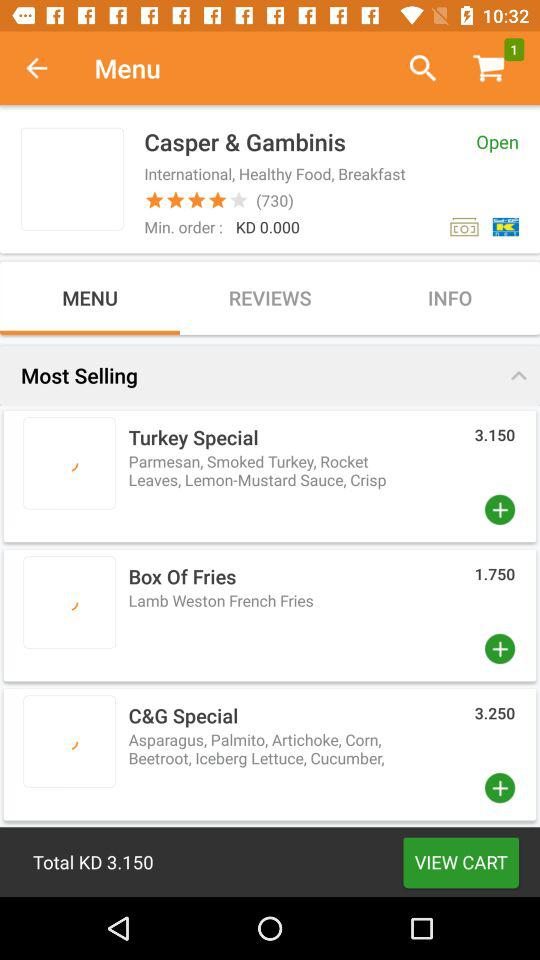What type of food is served? The types of food served are "International", "Healthy Food" and "Breakfast". 